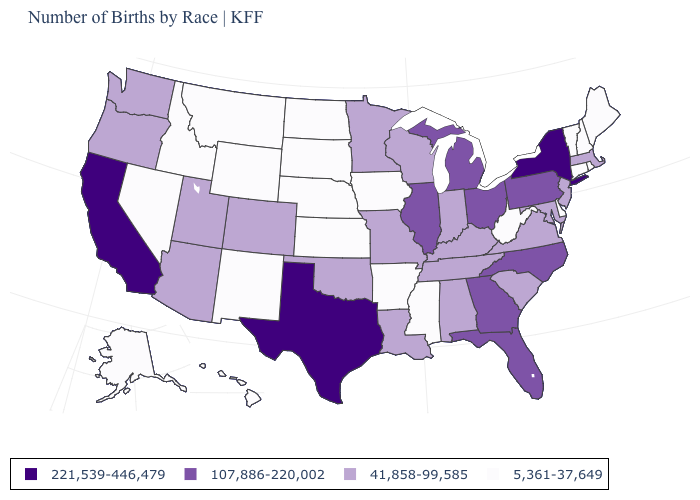What is the value of Rhode Island?
Be succinct. 5,361-37,649. How many symbols are there in the legend?
Write a very short answer. 4. What is the value of New York?
Short answer required. 221,539-446,479. Which states have the lowest value in the USA?
Be succinct. Alaska, Arkansas, Connecticut, Delaware, Hawaii, Idaho, Iowa, Kansas, Maine, Mississippi, Montana, Nebraska, Nevada, New Hampshire, New Mexico, North Dakota, Rhode Island, South Dakota, Vermont, West Virginia, Wyoming. What is the highest value in states that border Arkansas?
Answer briefly. 221,539-446,479. What is the highest value in the South ?
Give a very brief answer. 221,539-446,479. Does Georgia have the same value as Pennsylvania?
Keep it brief. Yes. What is the value of Wyoming?
Write a very short answer. 5,361-37,649. What is the value of Kansas?
Write a very short answer. 5,361-37,649. Is the legend a continuous bar?
Write a very short answer. No. Does Maine have the lowest value in the Northeast?
Be succinct. Yes. Name the states that have a value in the range 5,361-37,649?
Keep it brief. Alaska, Arkansas, Connecticut, Delaware, Hawaii, Idaho, Iowa, Kansas, Maine, Mississippi, Montana, Nebraska, Nevada, New Hampshire, New Mexico, North Dakota, Rhode Island, South Dakota, Vermont, West Virginia, Wyoming. Does New York have the highest value in the Northeast?
Give a very brief answer. Yes. Does the map have missing data?
Short answer required. No. Among the states that border Minnesota , does Wisconsin have the highest value?
Concise answer only. Yes. 